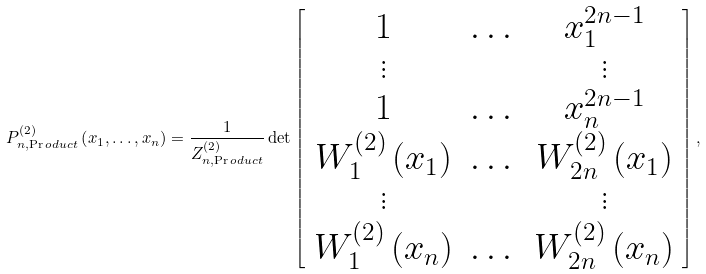Convert formula to latex. <formula><loc_0><loc_0><loc_500><loc_500>P _ { n , \Pr o d u c t } ^ { ( 2 ) } \left ( x _ { 1 } , \dots , x _ { n } \right ) = \frac { 1 } { Z _ { n , \Pr o d u c t } ^ { ( 2 ) } } \det \left [ \begin{array} { c c c } 1 & \dots & x _ { 1 } ^ { 2 n - 1 } \\ \vdots & & \vdots \\ 1 & \dots & x _ { n } ^ { 2 n - 1 } \\ W _ { 1 } ^ { ( 2 ) } \left ( x _ { 1 } \right ) & \dots & W _ { 2 n } ^ { ( 2 ) } \left ( x _ { 1 } \right ) \\ \vdots & & \vdots \\ W _ { 1 } ^ { ( 2 ) } \left ( x _ { n } \right ) & \dots & W _ { 2 n } ^ { ( 2 ) } \left ( x _ { n } \right ) \end{array} \right ] ,</formula> 